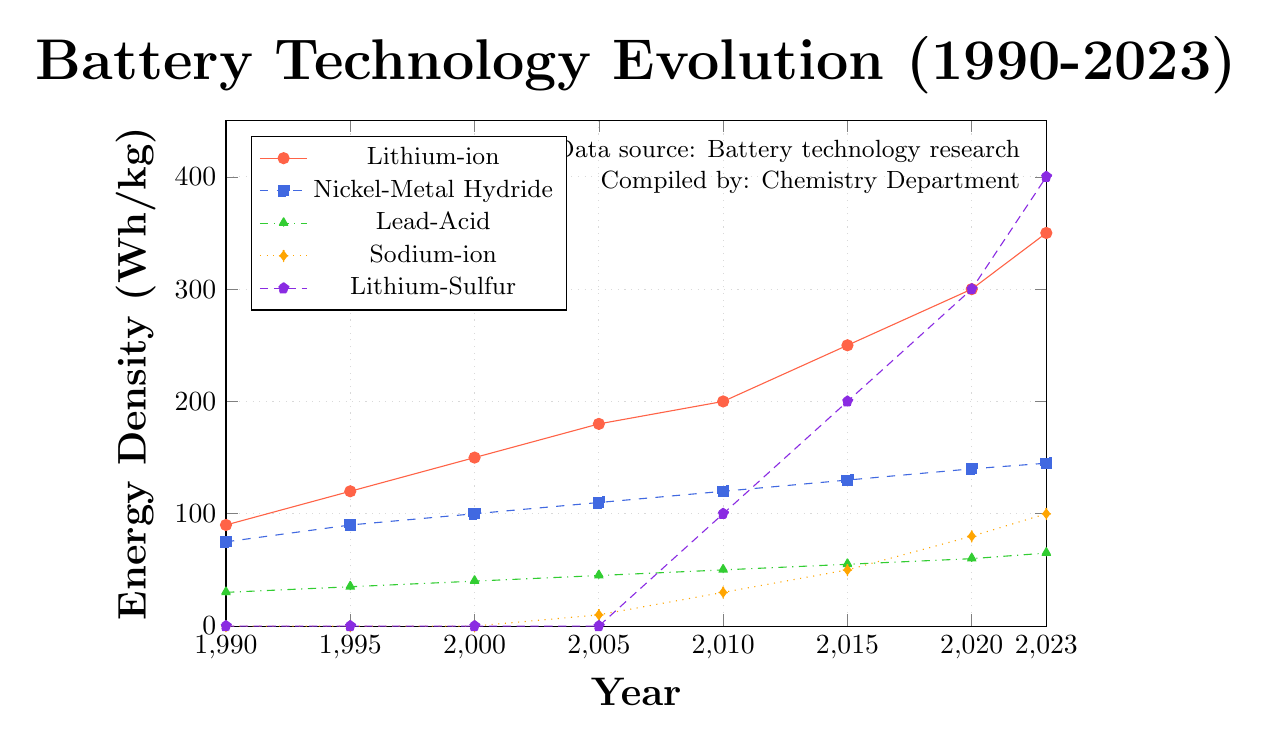What year did Lithium-Sulfur batteries first appear in the dataset? Observing the Lithium-Sulfur data series, the first non-zero data point appears at the year 2010 in the figure. This indicates Lithium-Sulfur batteries first appear in the dataset in 2010.
Answer: 2010 Which battery type shows the highest energy density in 2023? Looking at the endpoint of the year 2023 for all battery types, the Lithium-Sulfur battery reaches the highest energy density at 400 Wh/kg.
Answer: Lithium-Sulfur What is the total increase in energy density of Lithium-ion batteries from 1990 to 2023? The energy density of Lithium-ion batteries in 1990 is 90 Wh/kg and in 2023 is 350 Wh/kg. The increase is calculated as 350 - 90 = 260 Wh/kg.
Answer: 260 Wh/kg Between which two years did Sodium-ion batteries experience the largest increase in energy density? Observing the year-by-year progression for Sodium-ion, the largest increase is from 2015 (50 Wh/kg) to 2020 (80 Wh/kg), an increase of 30 Wh/kg.
Answer: 2015 to 2020 In 2010, compare the energy density of Nickel-Metal Hydride and Lead-Acid batteries, which one is higher and by how much? In 2010, the energy density for Nickel-Metal Hydride is 120 Wh/kg and for Lead-Acid, it is 50 Wh/kg. The difference is 120 - 50 = 70 Wh/kg, with Nickel-Metal Hydride being higher.
Answer: Nickel-Metal Hydride, by 70 Wh/kg Which battery type had the most consistent increase in energy density over the 30 years? By examining the slopes of all the battery types, Nickel-Metal Hydride shows a relatively steady and consistent increase in energy density from 75 Wh/kg in 1990 to 145 Wh/kg in 2023.
Answer: Nickel-Metal Hydride What was the energy density of Lead-Acid batteries in the year 2000, and how does it compare to 2023? In 2000, the energy density of Lead-Acid batteries was 40 Wh/kg. By 2023, it had increased to 65 Wh/kg, an increase of 25 Wh/kg.
Answer: 40 Wh/kg in 2000, increase by 25 Wh/kg in 2023 Compare the energy density growth trends from 2000 to 2015 for Lithium-ion and Lithium-Sulfur batteries. From 2000 to 2015, Lithium-ion increased from 150 Wh/kg to 250 Wh/kg, a growth of 100 Wh/kg. In the same period, Lithium-Sulfur increased from 0 Wh/kg to 200 Wh/kg, showing a higher growth but starting from zero.
Answer: Lithium-Sulfur grew more, from 0 to 200 Wh/kg How does the energy density of Sodium-ion batteries in 2015 compare to the energy density of Lithium-Sulfur batteries in 2010? In 2015, Sodium-ion batteries have an energy density of 50 Wh/kg, while in 2010, Lithium-Sulfur batteries have an energy density of 100 Wh/kg. Lithium-Sulfur in 2010 had double the energy density of Sodium-ion in 2015.
Answer: Lithium-Sulfur (2010) is higher by 50 Wh/kg What is the average energy density of Lithium-ion batteries across all years shown? Sum the energy densities of Lithium-ion for all years: 90 + 120 + 150 + 180 + 200 + 250 + 300 + 350 = 1640 Wh/kg. There are 8 years, so the average is 1640 / 8 = 205 Wh/kg.
Answer: 205 Wh/kg 